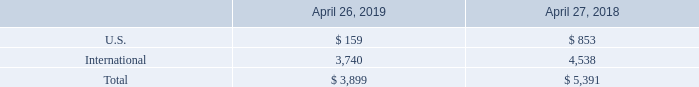16. Segment, Geographic, and Significant Customer Information
We operate in one industry segment: the design, manufacturing, marketing, and technical support of high-performance storage and data management solutions. We conduct business globally, and our sales and support activities are managed on a geographic basis. Our management reviews financial information presented on a consolidated basis, accompanied by disaggregated information it receives from our internal management system about revenues by geographic region, based on the location from which the customer relationship is managed, for purposes of allocating resources and evaluating financial performance. We do not allocate costs of revenues, research and development, sales and marketing, or general and administrative expenses to our geographic regions in this internal management reporting because management does not review operations or operating results, or make planning decisions, below the consolidated entity level.
The majority of our assets, excluding cash, cash equivalents, short-term investments and accounts receivable, were attributable to our domestic operations. The following table presents cash, cash equivalents and short-term investments held in the U.S. and internationally in various foreign subsidiaries (in millions):
Which years does the table provide information for cash, cash equivalents and short-term investments held? 2019, 2018. What were the assets from U.S. in 2019?
Answer scale should be: million. 159. What were the total assets in 2018?
Answer scale should be: million. 5,391. What was the change in international assets between 2018 and 2019?
Answer scale should be: million. 3,740-4,538
Answer: -798. What was the change in U.S. assets between 2018 and 2019?
Answer scale should be: million. 159-853
Answer: -694. What was the percentage change in the total assets between 2018 and 2019?
Answer scale should be: percent. (3,899-5,391)/5,391
Answer: -27.68. 